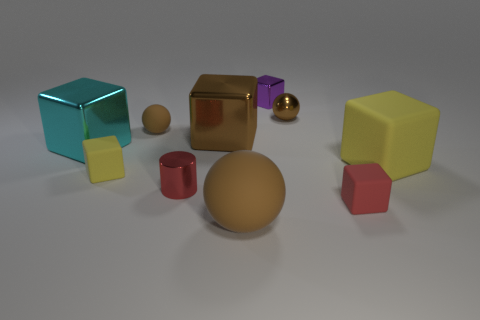How many tiny brown rubber balls are right of the matte cube to the left of the small rubber cube on the right side of the small purple cube?
Your answer should be very brief. 1. There is a large matte thing to the right of the red cube; does it have the same color as the large metallic thing that is to the right of the small brown rubber ball?
Ensure brevity in your answer.  No. Is there anything else of the same color as the shiny sphere?
Keep it short and to the point. Yes. There is a tiny matte block that is in front of the yellow block to the left of the big sphere; what color is it?
Offer a terse response. Red. Is there a brown sphere?
Ensure brevity in your answer.  Yes. There is a block that is to the right of the cyan metal object and left of the metal cylinder; what is its color?
Make the answer very short. Yellow. Is the size of the brown sphere in front of the big cyan metallic object the same as the sphere on the right side of the small purple object?
Keep it short and to the point. No. What number of other things are the same size as the red rubber thing?
Offer a very short reply. 5. What number of big spheres are behind the brown sphere on the left side of the big matte ball?
Give a very brief answer. 0. Are there fewer metal cylinders that are on the right side of the tiny red matte thing than big yellow cubes?
Make the answer very short. Yes. 